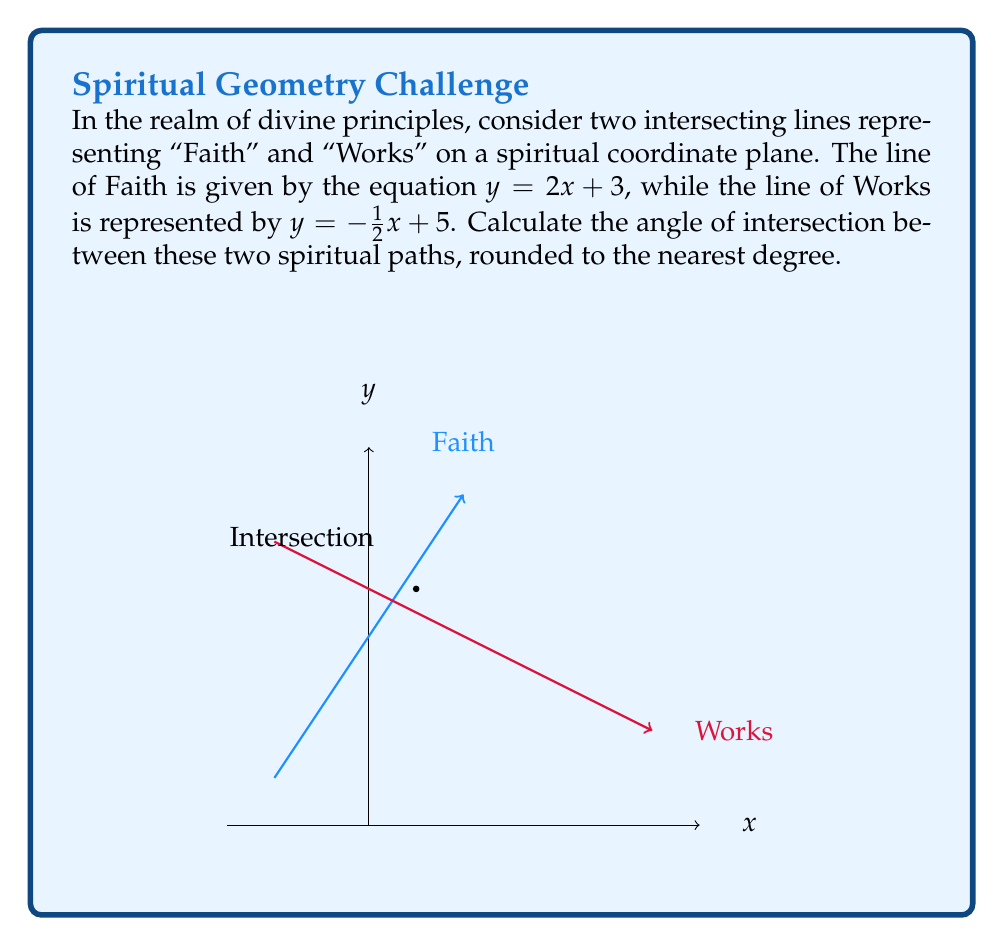Can you solve this math problem? To find the angle between two intersecting lines, we can use the formula:

$$ \tan \theta = \left|\frac{m_1 - m_2}{1 + m_1m_2}\right| $$

where $m_1$ and $m_2$ are the slopes of the two lines.

Step 1: Identify the slopes
- For the line of Faith: $y = 2x + 3$, so $m_1 = 2$
- For the line of Works: $y = -\frac{1}{2}x + 5$, so $m_2 = -\frac{1}{2}$

Step 2: Apply the formula
$$ \tan \theta = \left|\frac{2 - (-\frac{1}{2})}{1 + 2(-\frac{1}{2})}\right| = \left|\frac{2 + \frac{1}{2}}{1 - 1}\right| = \left|\frac{\frac{5}{2}}{0}\right| $$

Step 3: Interpret the result
The denominator is zero, which means $\tan \theta$ approaches infinity. This occurs when $\theta = 90°$.

Step 4: Verify perpendicularity
We can confirm this result by noting that the product of the slopes is -1:
$$ m_1 \cdot m_2 = 2 \cdot (-\frac{1}{2}) = -1 $$

This is the condition for perpendicular lines.

Therefore, the lines of Faith and Works intersect at a right angle, symbolizing the perfect balance and complementarity of these two divine principles in spiritual life.
Answer: The angle between the lines representing Faith and Works is 90°. 